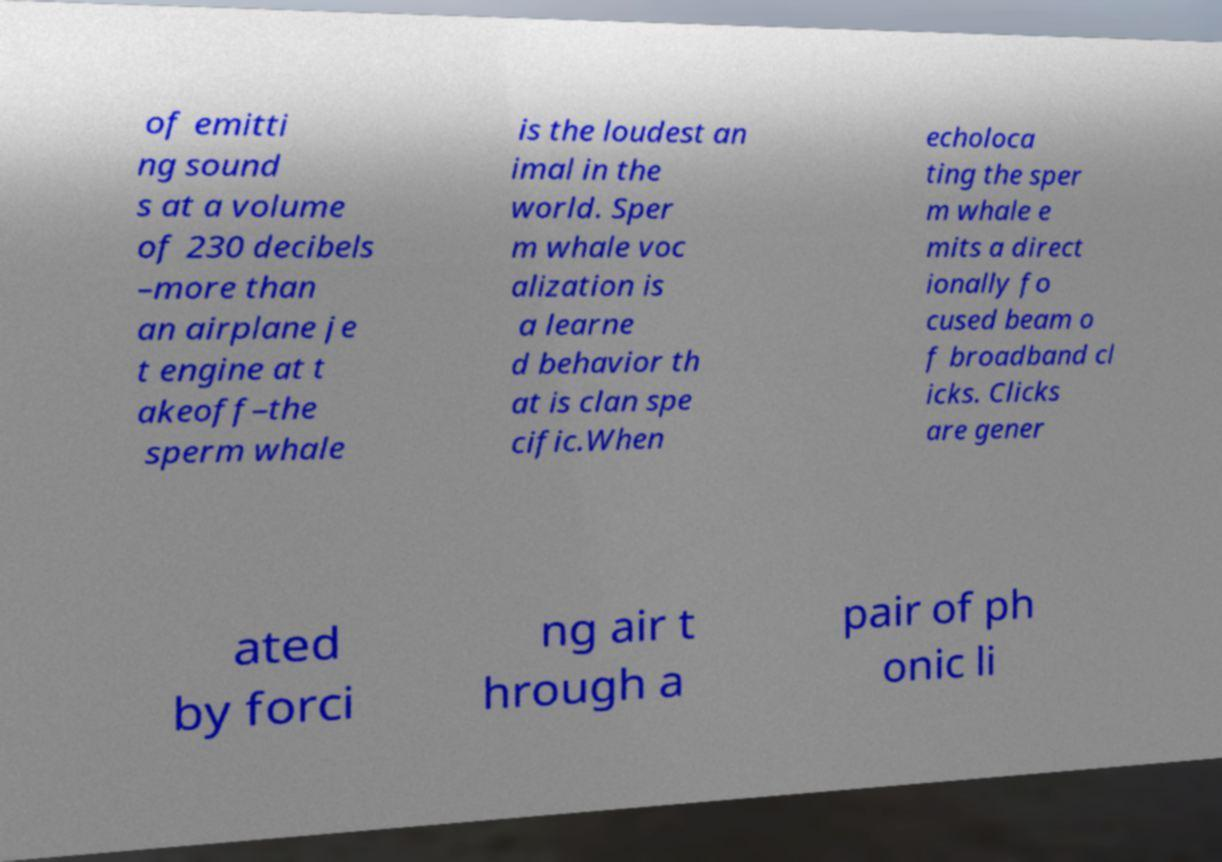Can you accurately transcribe the text from the provided image for me? of emitti ng sound s at a volume of 230 decibels –more than an airplane je t engine at t akeoff–the sperm whale is the loudest an imal in the world. Sper m whale voc alization is a learne d behavior th at is clan spe cific.When echoloca ting the sper m whale e mits a direct ionally fo cused beam o f broadband cl icks. Clicks are gener ated by forci ng air t hrough a pair of ph onic li 